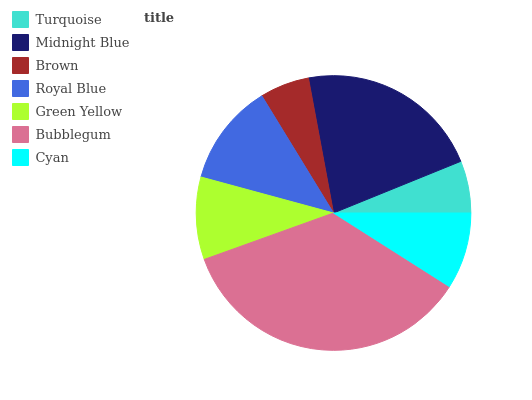Is Brown the minimum?
Answer yes or no. Yes. Is Bubblegum the maximum?
Answer yes or no. Yes. Is Midnight Blue the minimum?
Answer yes or no. No. Is Midnight Blue the maximum?
Answer yes or no. No. Is Midnight Blue greater than Turquoise?
Answer yes or no. Yes. Is Turquoise less than Midnight Blue?
Answer yes or no. Yes. Is Turquoise greater than Midnight Blue?
Answer yes or no. No. Is Midnight Blue less than Turquoise?
Answer yes or no. No. Is Green Yellow the high median?
Answer yes or no. Yes. Is Green Yellow the low median?
Answer yes or no. Yes. Is Royal Blue the high median?
Answer yes or no. No. Is Brown the low median?
Answer yes or no. No. 